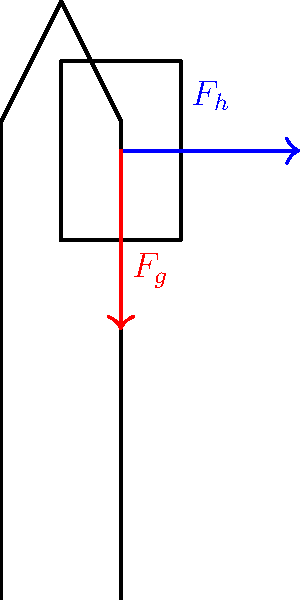While exploring Villapuram's temples with a backpack, you experience shoulder strain. If the weight of your backpack is 15 kg and you're leaning forward at a 20° angle to counterbalance the load, calculate the horizontal force ($F_h$) exerted on your shoulders. Assume $g = 9.8 m/s^2$. To solve this problem, we'll follow these steps:

1. Calculate the gravitational force ($F_g$) of the backpack:
   $F_g = mg = 15 \text{ kg} \times 9.8 \text{ m/s}^2 = 147 \text{ N}$

2. Decompose the gravitational force into its vertical and horizontal components:
   - Vertical component: $F_v = F_g \cos(20°)$
   - Horizontal component: $F_h = F_g \sin(20°)$

3. Calculate the horizontal force ($F_h$):
   $F_h = F_g \sin(20°) = 147 \text{ N} \times \sin(20°) = 147 \text{ N} \times 0.342 = 50.27 \text{ N}$

The horizontal force exerted on your shoulders is approximately 50.27 N. This force is what causes the strain you feel while carrying the backpack and leaning forward to counterbalance the load.
Answer: $50.27 \text{ N}$ 